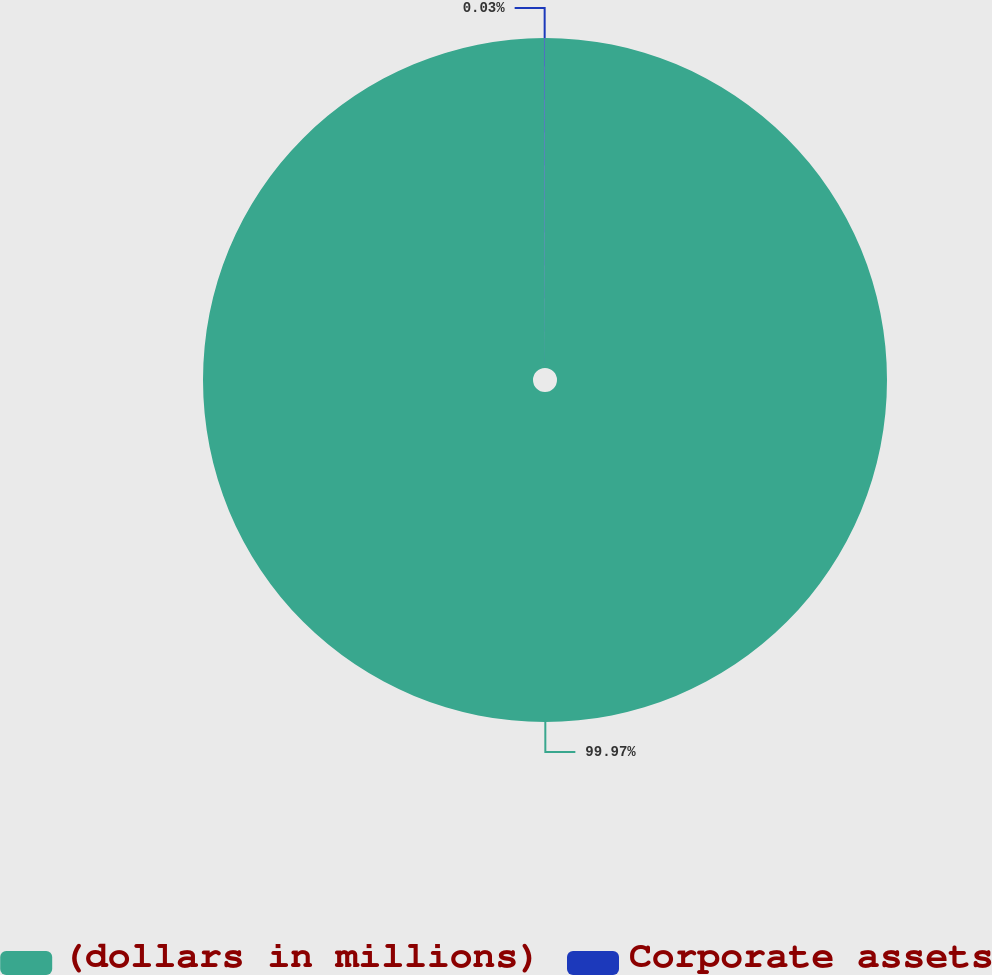Convert chart to OTSL. <chart><loc_0><loc_0><loc_500><loc_500><pie_chart><fcel>(dollars in millions)<fcel>Corporate assets<nl><fcel>99.97%<fcel>0.03%<nl></chart> 